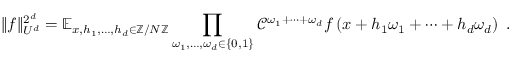Convert formula to latex. <formula><loc_0><loc_0><loc_500><loc_500>\| f \| _ { U ^ { d } } ^ { 2 ^ { d } } = \mathbb { E } _ { x , h _ { 1 } , \dots , h _ { d } \in \mathbb { Z } / N \mathbb { Z } } \prod _ { \omega _ { 1 } , \dots , \omega _ { d } \in \{ 0 , 1 \} } \mathcal { C } ^ { \omega _ { 1 } + \cdots + \omega _ { d } } f \left ( { x + h _ { 1 } \omega _ { 1 } + \cdots + h _ { d } \omega _ { d } } \right ) \ .</formula> 